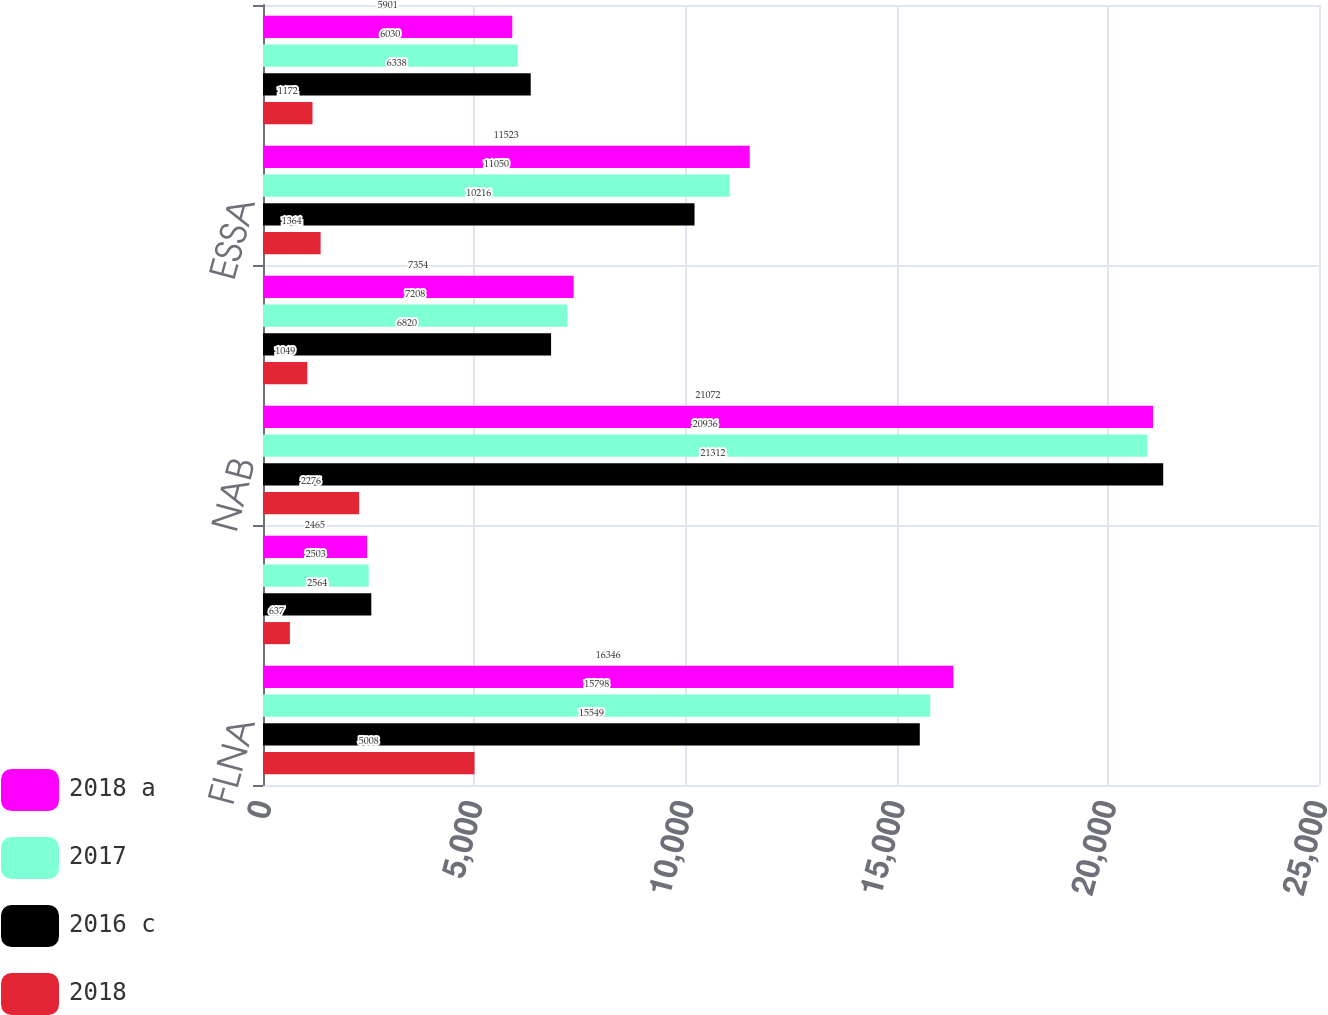<chart> <loc_0><loc_0><loc_500><loc_500><stacked_bar_chart><ecel><fcel>FLNA<fcel>QFNA<fcel>NAB<fcel>Latin America<fcel>ESSA<fcel>AMENA<nl><fcel>2018 a<fcel>16346<fcel>2465<fcel>21072<fcel>7354<fcel>11523<fcel>5901<nl><fcel>2017<fcel>15798<fcel>2503<fcel>20936<fcel>7208<fcel>11050<fcel>6030<nl><fcel>2016 c<fcel>15549<fcel>2564<fcel>21312<fcel>6820<fcel>10216<fcel>6338<nl><fcel>2018<fcel>5008<fcel>637<fcel>2276<fcel>1049<fcel>1364<fcel>1172<nl></chart> 